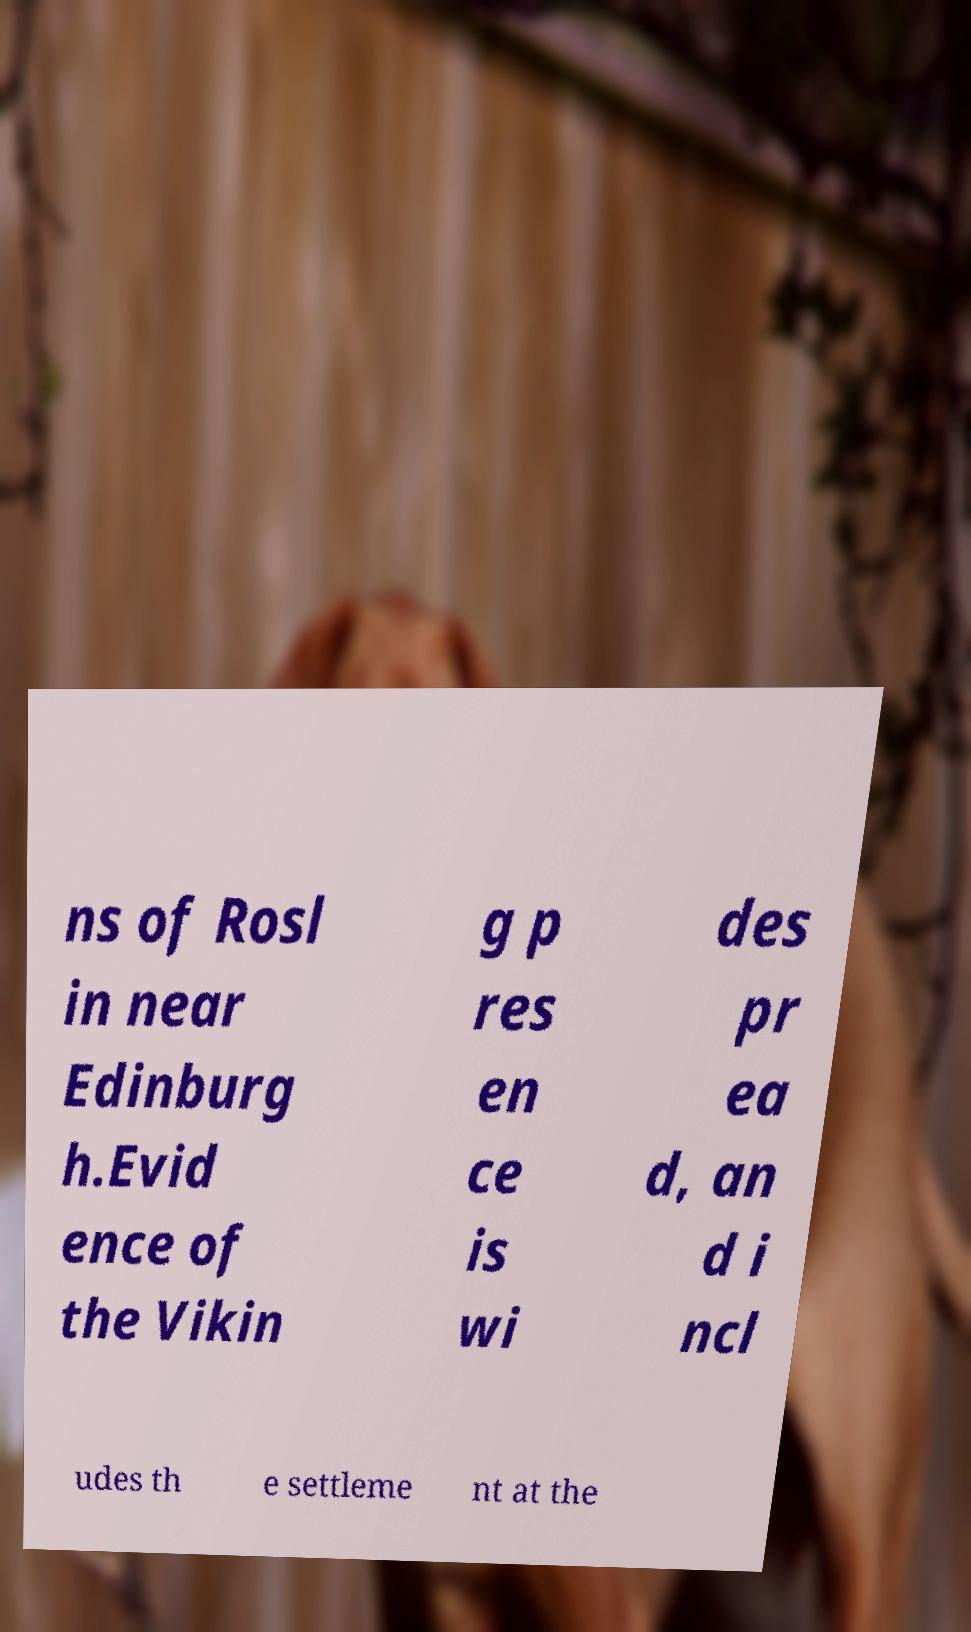Please read and relay the text visible in this image. What does it say? ns of Rosl in near Edinburg h.Evid ence of the Vikin g p res en ce is wi des pr ea d, an d i ncl udes th e settleme nt at the 